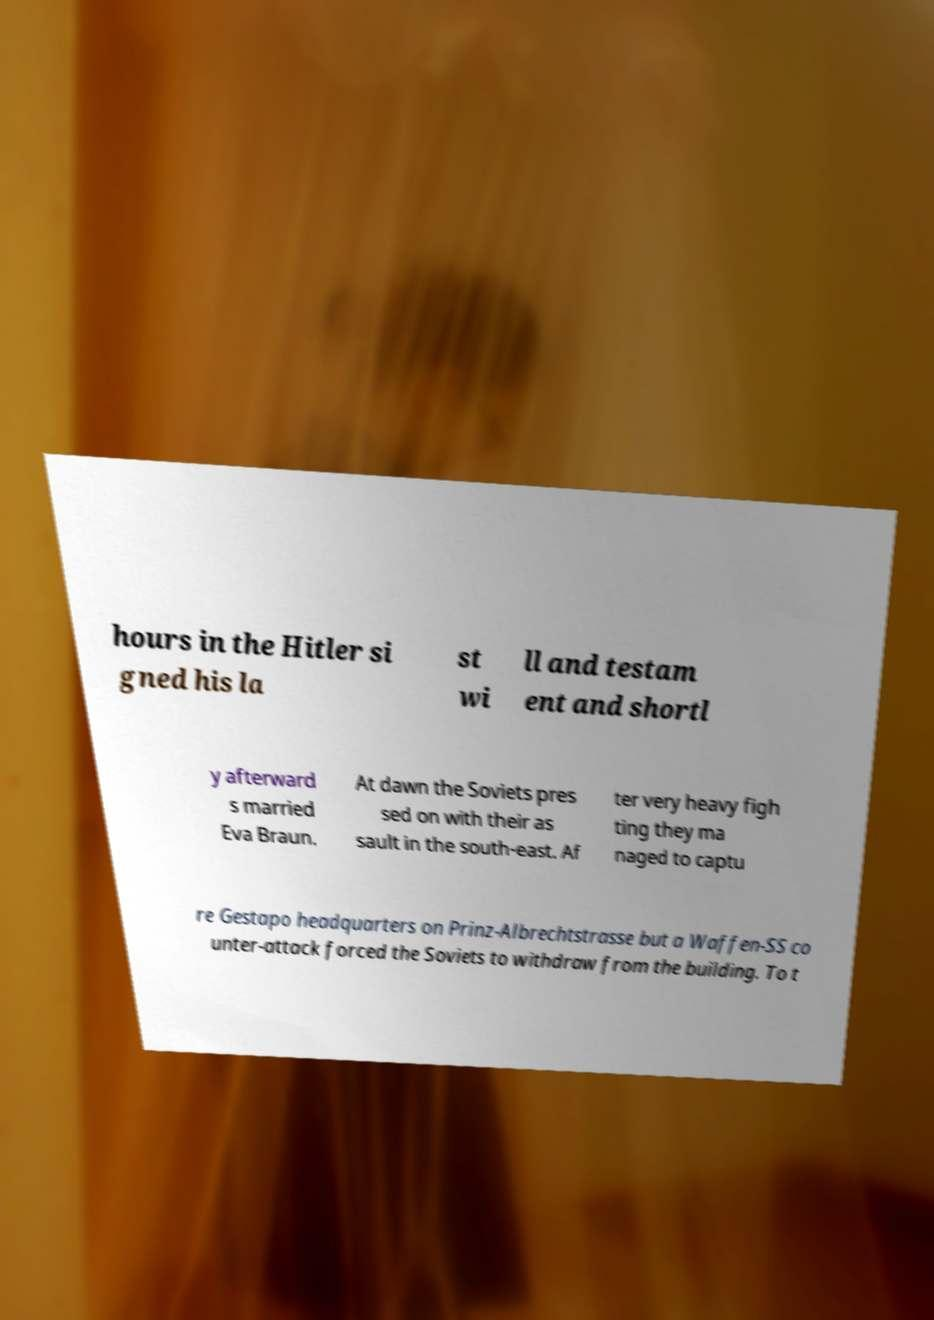Could you extract and type out the text from this image? hours in the Hitler si gned his la st wi ll and testam ent and shortl y afterward s married Eva Braun. At dawn the Soviets pres sed on with their as sault in the south-east. Af ter very heavy figh ting they ma naged to captu re Gestapo headquarters on Prinz-Albrechtstrasse but a Waffen-SS co unter-attack forced the Soviets to withdraw from the building. To t 